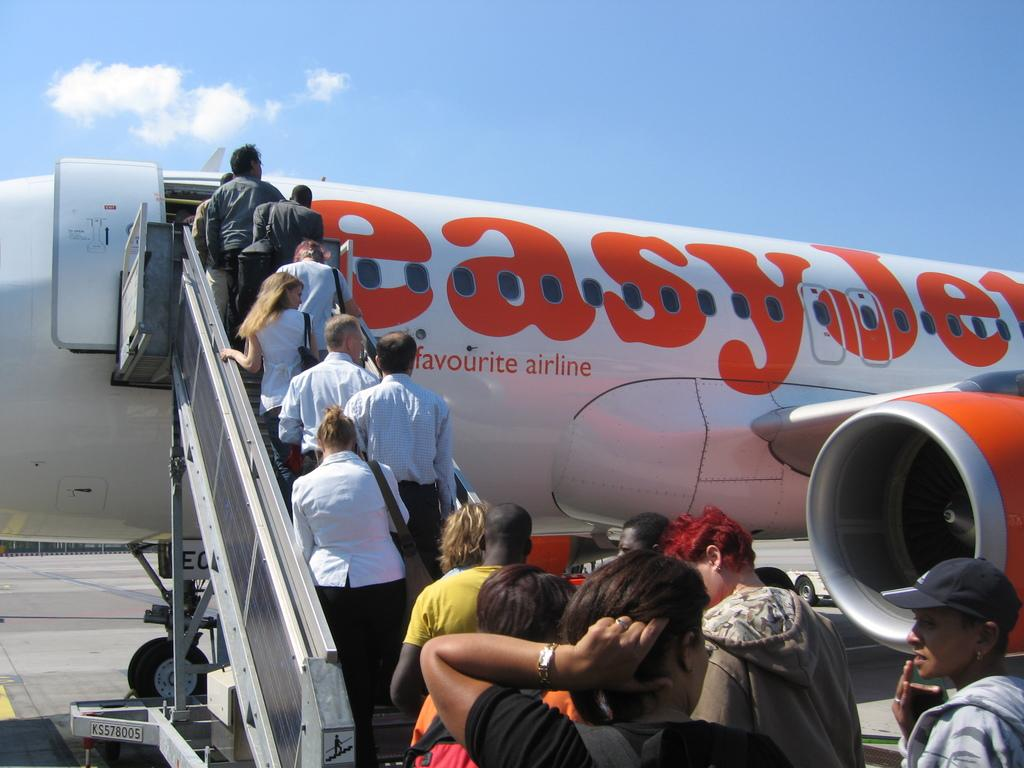<image>
Share a concise interpretation of the image provided. A group of travelers board an EasyJet airline flight. 